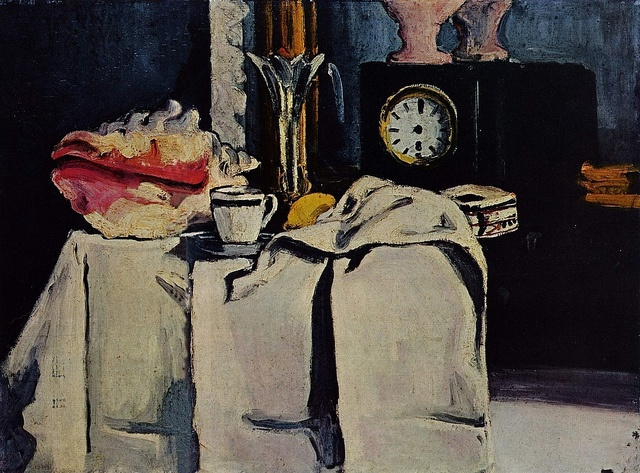Describe the objects in this image and their specific colors. I can see vase in black, gray, tan, and darkgray tones, clock in black, darkgray, and gray tones, and cup in black, darkgray, and gray tones in this image. 